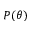Convert formula to latex. <formula><loc_0><loc_0><loc_500><loc_500>P ( \theta )</formula> 